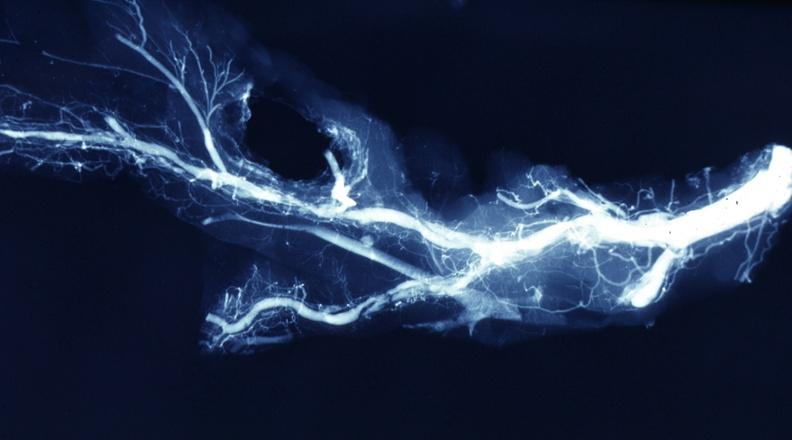s pus in test tube present?
Answer the question using a single word or phrase. No 